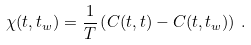<formula> <loc_0><loc_0><loc_500><loc_500>\chi ( t , t _ { w } ) = \frac { 1 } { T } \left ( C ( t , t ) - C ( t , t _ { w } ) \right ) \, .</formula> 